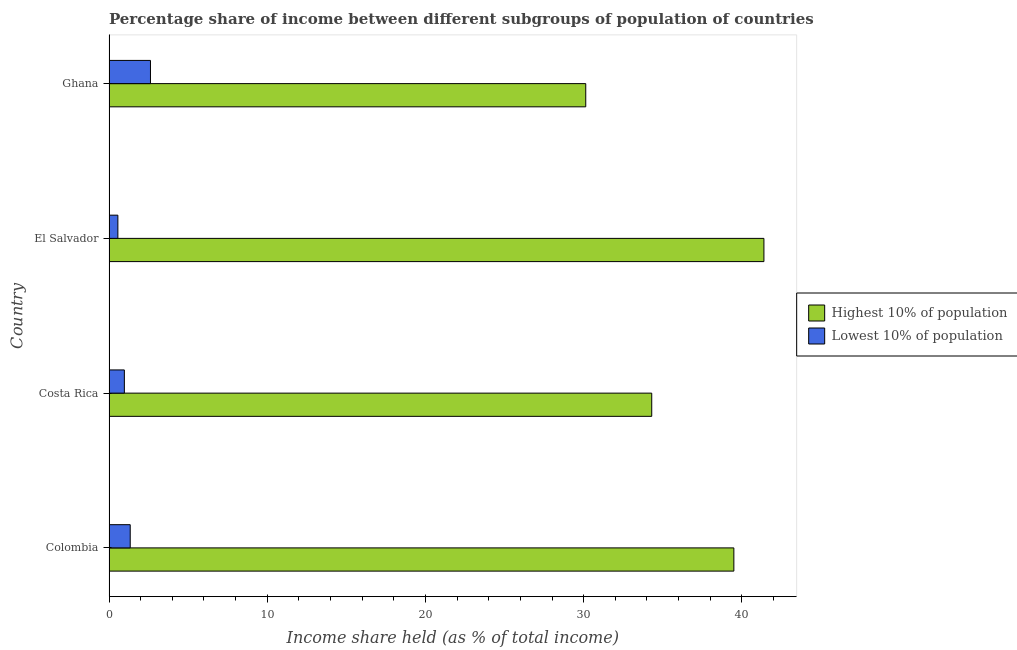How many different coloured bars are there?
Your response must be concise. 2. How many groups of bars are there?
Offer a very short reply. 4. Are the number of bars per tick equal to the number of legend labels?
Your answer should be compact. Yes. Are the number of bars on each tick of the Y-axis equal?
Give a very brief answer. Yes. How many bars are there on the 4th tick from the bottom?
Provide a succinct answer. 2. What is the label of the 4th group of bars from the top?
Your response must be concise. Colombia. What is the income share held by highest 10% of the population in Costa Rica?
Keep it short and to the point. 34.3. Across all countries, what is the maximum income share held by highest 10% of the population?
Ensure brevity in your answer.  41.39. Across all countries, what is the minimum income share held by lowest 10% of the population?
Keep it short and to the point. 0.56. In which country was the income share held by lowest 10% of the population maximum?
Offer a terse response. Ghana. In which country was the income share held by lowest 10% of the population minimum?
Offer a terse response. El Salvador. What is the total income share held by highest 10% of the population in the graph?
Provide a short and direct response. 145.31. What is the difference between the income share held by highest 10% of the population in Colombia and that in Costa Rica?
Ensure brevity in your answer.  5.19. What is the difference between the income share held by highest 10% of the population in Costa Rica and the income share held by lowest 10% of the population in Ghana?
Provide a short and direct response. 31.68. What is the average income share held by lowest 10% of the population per country?
Provide a succinct answer. 1.37. What is the difference between the income share held by highest 10% of the population and income share held by lowest 10% of the population in Ghana?
Keep it short and to the point. 27.51. In how many countries, is the income share held by lowest 10% of the population greater than 4 %?
Your answer should be very brief. 0. What is the ratio of the income share held by lowest 10% of the population in El Salvador to that in Ghana?
Your answer should be compact. 0.21. Is the income share held by highest 10% of the population in Costa Rica less than that in El Salvador?
Your answer should be compact. Yes. Is the difference between the income share held by lowest 10% of the population in Costa Rica and Ghana greater than the difference between the income share held by highest 10% of the population in Costa Rica and Ghana?
Provide a succinct answer. No. What is the difference between the highest and the lowest income share held by highest 10% of the population?
Your answer should be compact. 11.26. In how many countries, is the income share held by lowest 10% of the population greater than the average income share held by lowest 10% of the population taken over all countries?
Make the answer very short. 1. Is the sum of the income share held by highest 10% of the population in Costa Rica and Ghana greater than the maximum income share held by lowest 10% of the population across all countries?
Give a very brief answer. Yes. What does the 1st bar from the top in El Salvador represents?
Keep it short and to the point. Lowest 10% of population. What does the 1st bar from the bottom in Ghana represents?
Your answer should be compact. Highest 10% of population. Are all the bars in the graph horizontal?
Give a very brief answer. Yes. How many countries are there in the graph?
Offer a terse response. 4. Are the values on the major ticks of X-axis written in scientific E-notation?
Provide a short and direct response. No. How are the legend labels stacked?
Your answer should be compact. Vertical. What is the title of the graph?
Offer a terse response. Percentage share of income between different subgroups of population of countries. Does "Forest" appear as one of the legend labels in the graph?
Make the answer very short. No. What is the label or title of the X-axis?
Offer a terse response. Income share held (as % of total income). What is the Income share held (as % of total income) in Highest 10% of population in Colombia?
Provide a succinct answer. 39.49. What is the Income share held (as % of total income) of Lowest 10% of population in Colombia?
Your answer should be compact. 1.34. What is the Income share held (as % of total income) of Highest 10% of population in Costa Rica?
Make the answer very short. 34.3. What is the Income share held (as % of total income) in Highest 10% of population in El Salvador?
Offer a very short reply. 41.39. What is the Income share held (as % of total income) of Lowest 10% of population in El Salvador?
Make the answer very short. 0.56. What is the Income share held (as % of total income) of Highest 10% of population in Ghana?
Provide a succinct answer. 30.13. What is the Income share held (as % of total income) in Lowest 10% of population in Ghana?
Keep it short and to the point. 2.62. Across all countries, what is the maximum Income share held (as % of total income) in Highest 10% of population?
Your response must be concise. 41.39. Across all countries, what is the maximum Income share held (as % of total income) in Lowest 10% of population?
Ensure brevity in your answer.  2.62. Across all countries, what is the minimum Income share held (as % of total income) of Highest 10% of population?
Give a very brief answer. 30.13. Across all countries, what is the minimum Income share held (as % of total income) of Lowest 10% of population?
Ensure brevity in your answer.  0.56. What is the total Income share held (as % of total income) of Highest 10% of population in the graph?
Ensure brevity in your answer.  145.31. What is the total Income share held (as % of total income) of Lowest 10% of population in the graph?
Provide a short and direct response. 5.49. What is the difference between the Income share held (as % of total income) of Highest 10% of population in Colombia and that in Costa Rica?
Ensure brevity in your answer.  5.19. What is the difference between the Income share held (as % of total income) of Lowest 10% of population in Colombia and that in Costa Rica?
Make the answer very short. 0.37. What is the difference between the Income share held (as % of total income) of Highest 10% of population in Colombia and that in El Salvador?
Offer a very short reply. -1.9. What is the difference between the Income share held (as % of total income) in Lowest 10% of population in Colombia and that in El Salvador?
Make the answer very short. 0.78. What is the difference between the Income share held (as % of total income) in Highest 10% of population in Colombia and that in Ghana?
Provide a short and direct response. 9.36. What is the difference between the Income share held (as % of total income) in Lowest 10% of population in Colombia and that in Ghana?
Give a very brief answer. -1.28. What is the difference between the Income share held (as % of total income) in Highest 10% of population in Costa Rica and that in El Salvador?
Give a very brief answer. -7.09. What is the difference between the Income share held (as % of total income) in Lowest 10% of population in Costa Rica and that in El Salvador?
Provide a short and direct response. 0.41. What is the difference between the Income share held (as % of total income) in Highest 10% of population in Costa Rica and that in Ghana?
Provide a short and direct response. 4.17. What is the difference between the Income share held (as % of total income) in Lowest 10% of population in Costa Rica and that in Ghana?
Provide a short and direct response. -1.65. What is the difference between the Income share held (as % of total income) in Highest 10% of population in El Salvador and that in Ghana?
Offer a very short reply. 11.26. What is the difference between the Income share held (as % of total income) of Lowest 10% of population in El Salvador and that in Ghana?
Offer a terse response. -2.06. What is the difference between the Income share held (as % of total income) of Highest 10% of population in Colombia and the Income share held (as % of total income) of Lowest 10% of population in Costa Rica?
Keep it short and to the point. 38.52. What is the difference between the Income share held (as % of total income) in Highest 10% of population in Colombia and the Income share held (as % of total income) in Lowest 10% of population in El Salvador?
Provide a short and direct response. 38.93. What is the difference between the Income share held (as % of total income) in Highest 10% of population in Colombia and the Income share held (as % of total income) in Lowest 10% of population in Ghana?
Keep it short and to the point. 36.87. What is the difference between the Income share held (as % of total income) of Highest 10% of population in Costa Rica and the Income share held (as % of total income) of Lowest 10% of population in El Salvador?
Provide a succinct answer. 33.74. What is the difference between the Income share held (as % of total income) in Highest 10% of population in Costa Rica and the Income share held (as % of total income) in Lowest 10% of population in Ghana?
Provide a succinct answer. 31.68. What is the difference between the Income share held (as % of total income) in Highest 10% of population in El Salvador and the Income share held (as % of total income) in Lowest 10% of population in Ghana?
Your answer should be compact. 38.77. What is the average Income share held (as % of total income) of Highest 10% of population per country?
Offer a terse response. 36.33. What is the average Income share held (as % of total income) of Lowest 10% of population per country?
Ensure brevity in your answer.  1.37. What is the difference between the Income share held (as % of total income) in Highest 10% of population and Income share held (as % of total income) in Lowest 10% of population in Colombia?
Ensure brevity in your answer.  38.15. What is the difference between the Income share held (as % of total income) of Highest 10% of population and Income share held (as % of total income) of Lowest 10% of population in Costa Rica?
Make the answer very short. 33.33. What is the difference between the Income share held (as % of total income) of Highest 10% of population and Income share held (as % of total income) of Lowest 10% of population in El Salvador?
Make the answer very short. 40.83. What is the difference between the Income share held (as % of total income) in Highest 10% of population and Income share held (as % of total income) in Lowest 10% of population in Ghana?
Provide a short and direct response. 27.51. What is the ratio of the Income share held (as % of total income) of Highest 10% of population in Colombia to that in Costa Rica?
Ensure brevity in your answer.  1.15. What is the ratio of the Income share held (as % of total income) of Lowest 10% of population in Colombia to that in Costa Rica?
Keep it short and to the point. 1.38. What is the ratio of the Income share held (as % of total income) in Highest 10% of population in Colombia to that in El Salvador?
Your answer should be compact. 0.95. What is the ratio of the Income share held (as % of total income) of Lowest 10% of population in Colombia to that in El Salvador?
Keep it short and to the point. 2.39. What is the ratio of the Income share held (as % of total income) in Highest 10% of population in Colombia to that in Ghana?
Your answer should be very brief. 1.31. What is the ratio of the Income share held (as % of total income) in Lowest 10% of population in Colombia to that in Ghana?
Keep it short and to the point. 0.51. What is the ratio of the Income share held (as % of total income) of Highest 10% of population in Costa Rica to that in El Salvador?
Ensure brevity in your answer.  0.83. What is the ratio of the Income share held (as % of total income) of Lowest 10% of population in Costa Rica to that in El Salvador?
Your answer should be very brief. 1.73. What is the ratio of the Income share held (as % of total income) of Highest 10% of population in Costa Rica to that in Ghana?
Provide a short and direct response. 1.14. What is the ratio of the Income share held (as % of total income) in Lowest 10% of population in Costa Rica to that in Ghana?
Keep it short and to the point. 0.37. What is the ratio of the Income share held (as % of total income) in Highest 10% of population in El Salvador to that in Ghana?
Your response must be concise. 1.37. What is the ratio of the Income share held (as % of total income) in Lowest 10% of population in El Salvador to that in Ghana?
Provide a short and direct response. 0.21. What is the difference between the highest and the second highest Income share held (as % of total income) of Lowest 10% of population?
Keep it short and to the point. 1.28. What is the difference between the highest and the lowest Income share held (as % of total income) in Highest 10% of population?
Your answer should be very brief. 11.26. What is the difference between the highest and the lowest Income share held (as % of total income) in Lowest 10% of population?
Give a very brief answer. 2.06. 